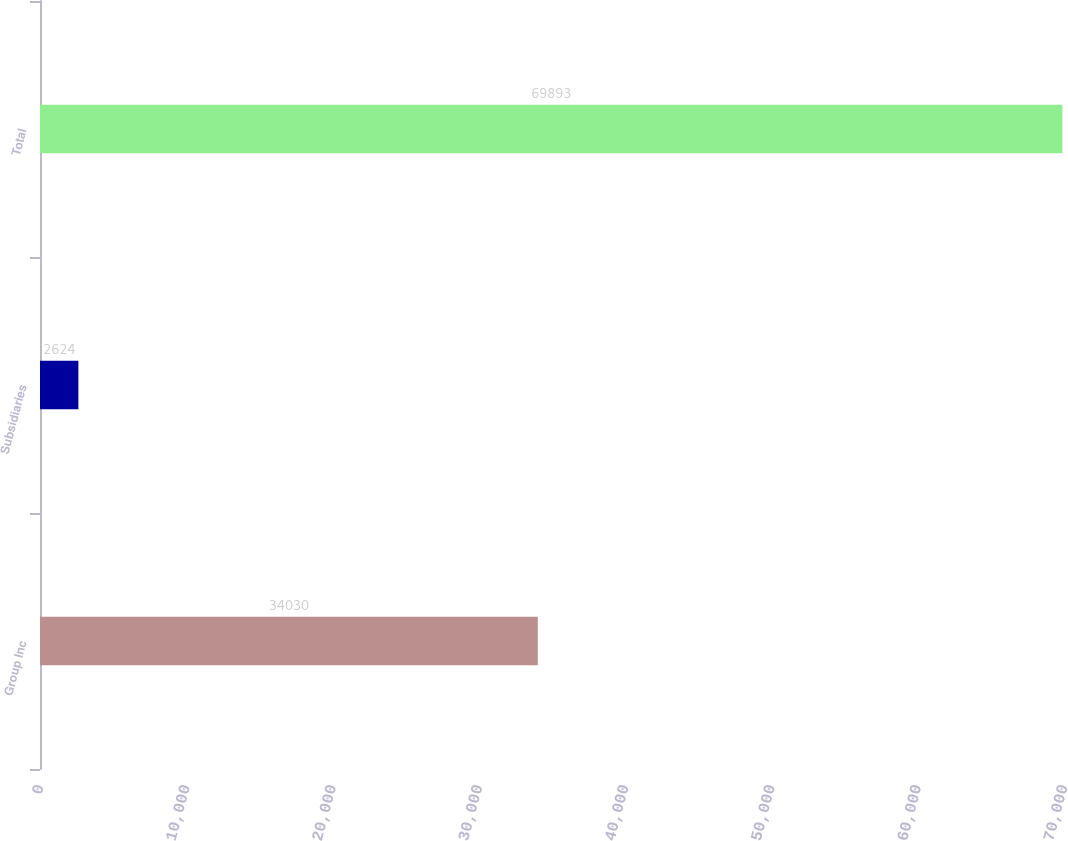Convert chart. <chart><loc_0><loc_0><loc_500><loc_500><bar_chart><fcel>Group Inc<fcel>Subsidiaries<fcel>Total<nl><fcel>34030<fcel>2624<fcel>69893<nl></chart> 